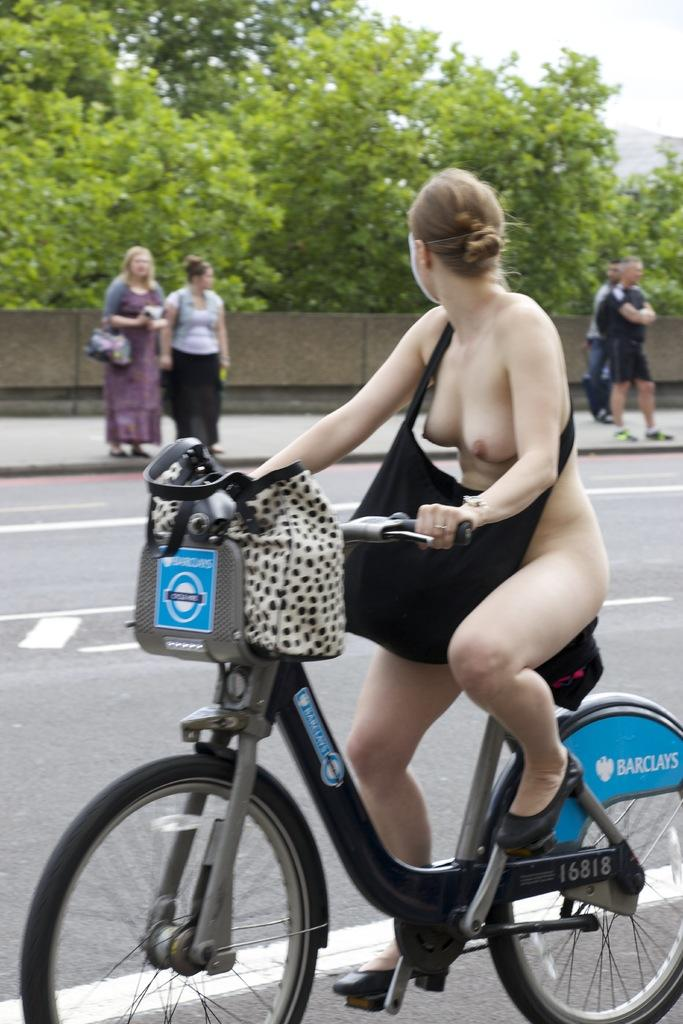Who is the main subject in the image? There is a woman in the image. What is the woman doing in the image? The woman is riding a bicycle. Where is the woman located in the image? The woman is on the road. What is the woman carrying in the image? The woman is wearing a handbag. What type of vegetation can be seen in the image? There is a tree visible in the image. What else can be seen in the image besides the woman and the tree? There are people standing on the footpath. What type of boot can be seen on the woman's foot in the image? There is no boot visible on the woman's foot in the image; she is wearing shoes suitable for riding a bicycle. 